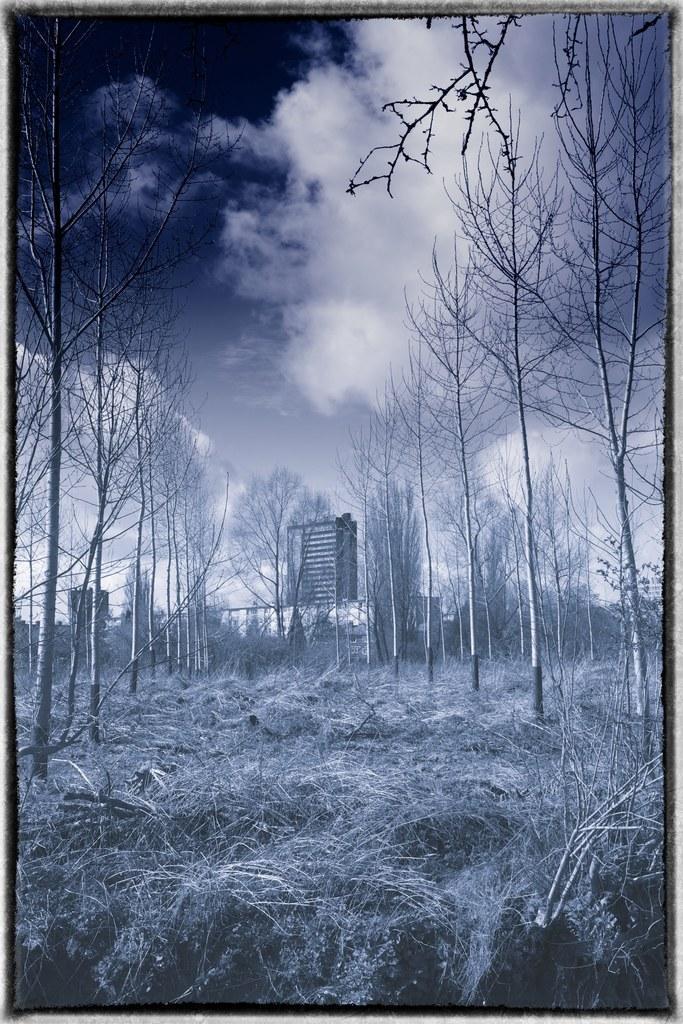In one or two sentences, can you explain what this image depicts? Here at the bottom we can see grass on the ground and to left and right side we can see bare trees. In the background there are trees,hoarding,an object and clouds in the sky. 